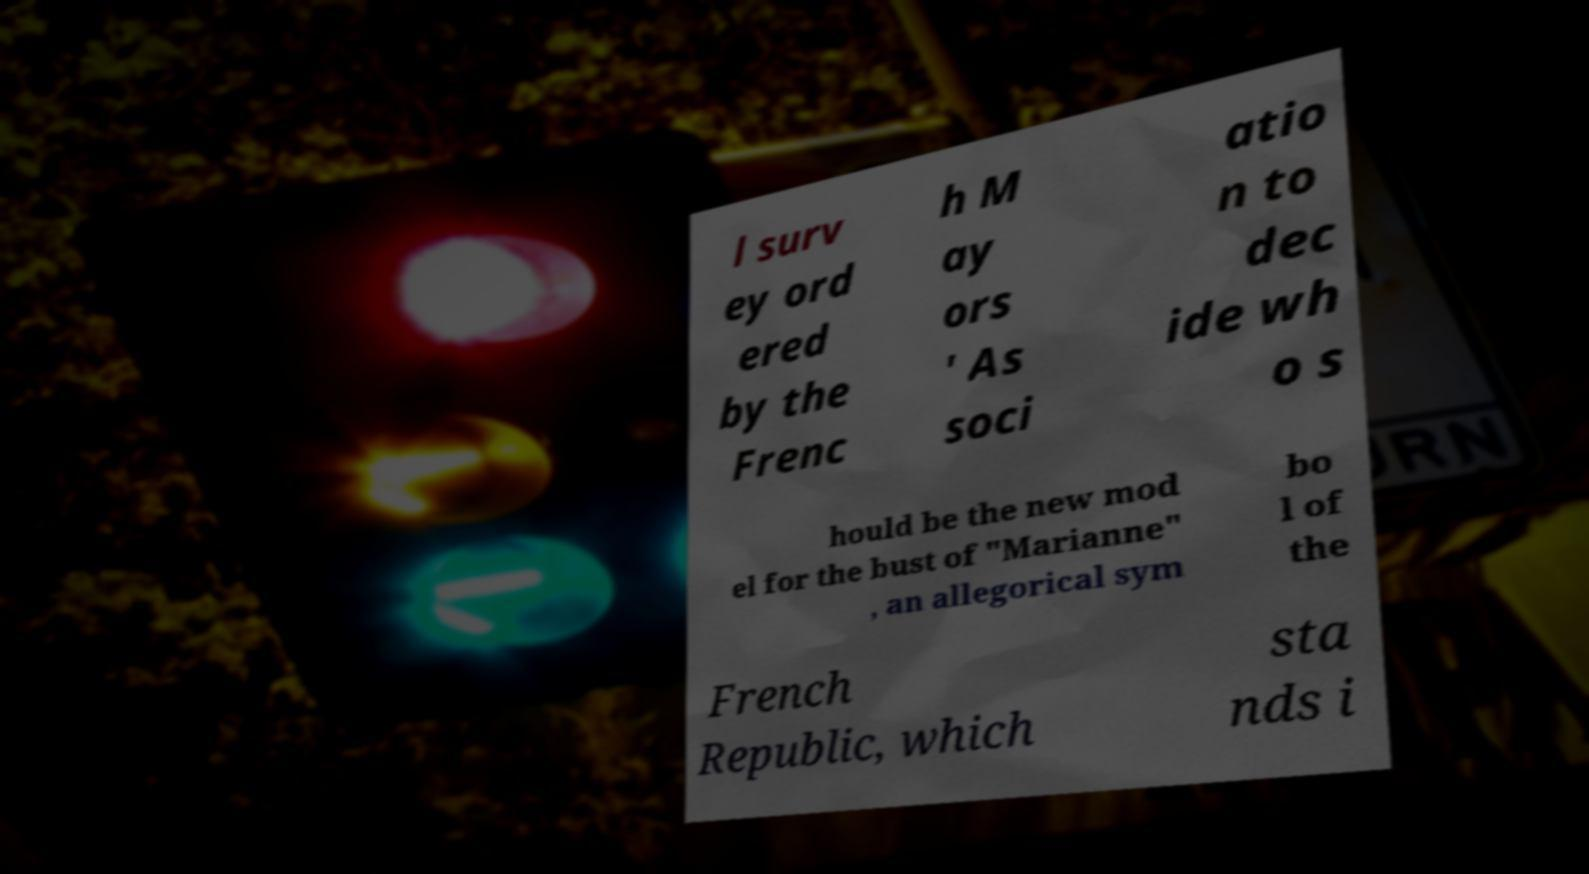Could you assist in decoding the text presented in this image and type it out clearly? l surv ey ord ered by the Frenc h M ay ors ' As soci atio n to dec ide wh o s hould be the new mod el for the bust of "Marianne" , an allegorical sym bo l of the French Republic, which sta nds i 